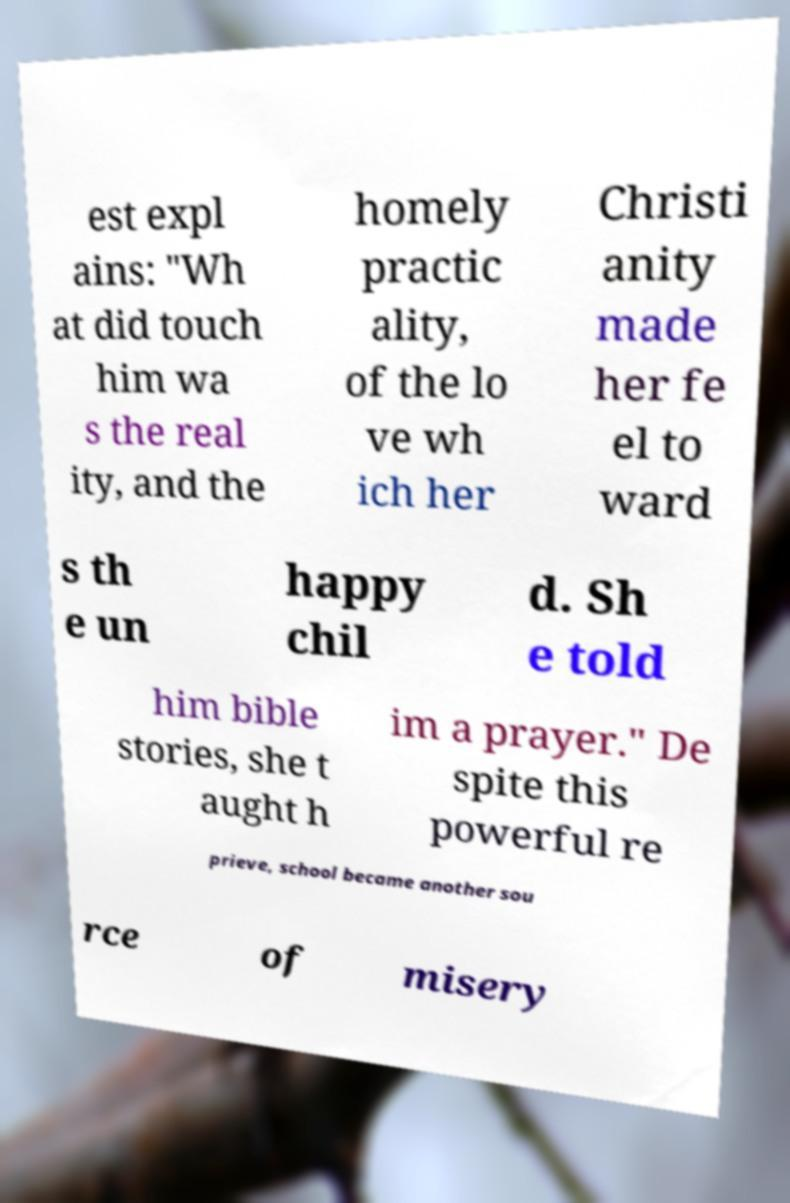For documentation purposes, I need the text within this image transcribed. Could you provide that? est expl ains: "Wh at did touch him wa s the real ity, and the homely practic ality, of the lo ve wh ich her Christi anity made her fe el to ward s th e un happy chil d. Sh e told him bible stories, she t aught h im a prayer." De spite this powerful re prieve, school became another sou rce of misery 